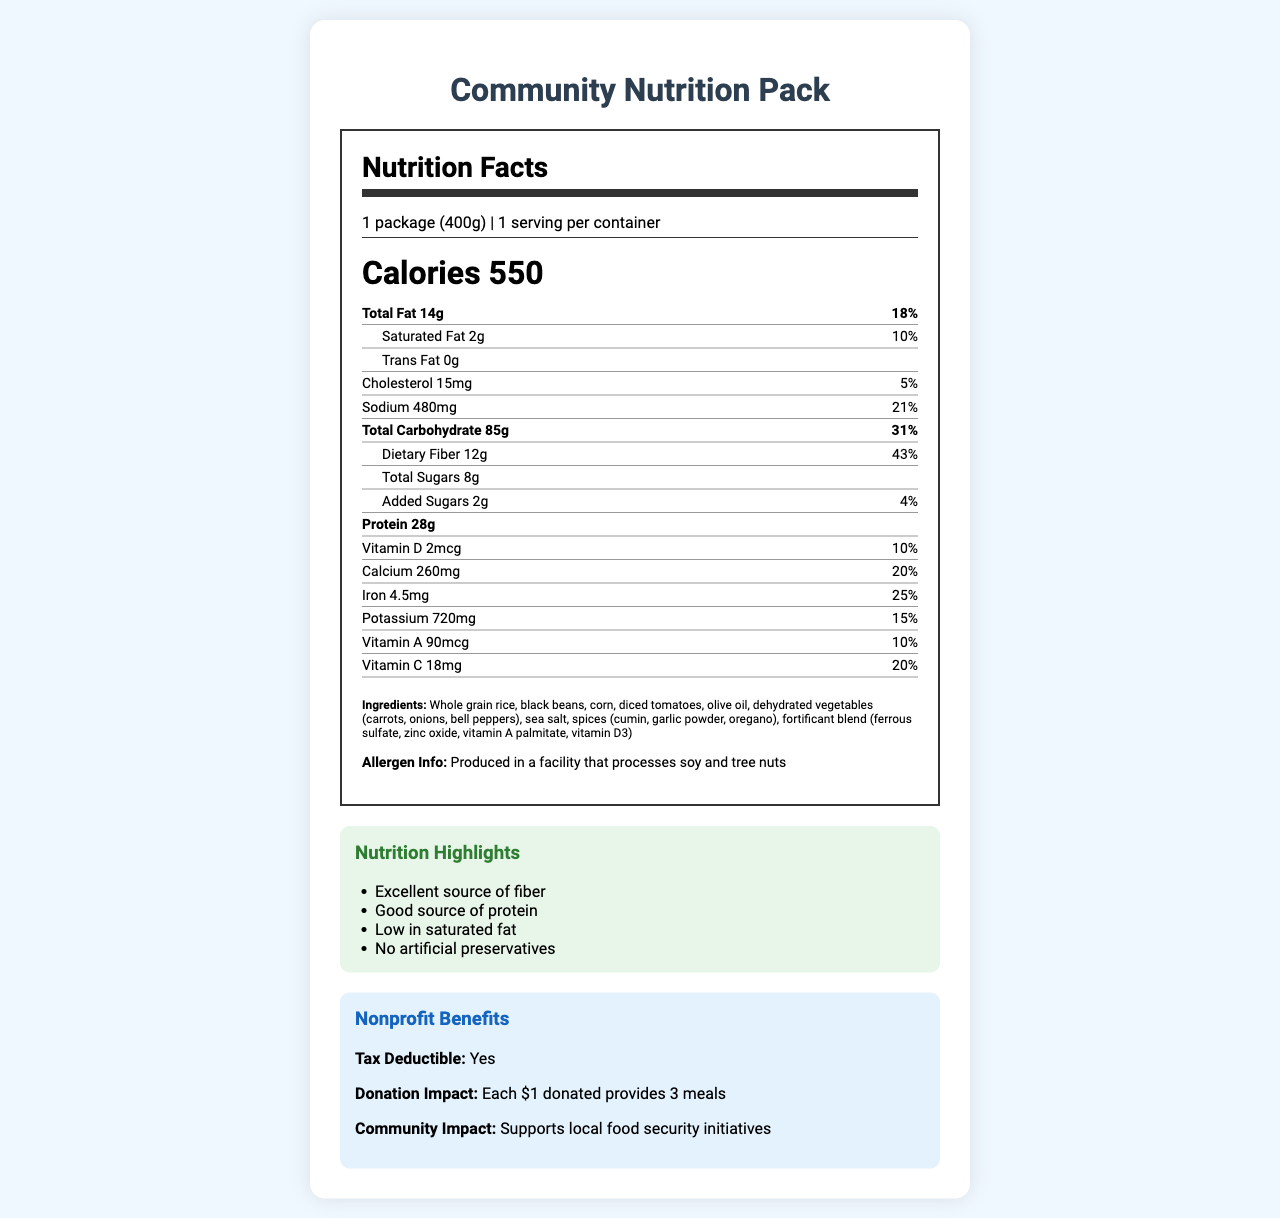what is the name of the product? The name of the product is clearly labeled at the top of the document.
Answer: Community Nutrition Pack how many servings per container are there? The document specifies "servings per container: 1" under the serving information.
Answer: 1 how many grams of dietary fiber does the product have? The amount of dietary fiber is listed as "Dietary Fiber 12g".
Answer: 12g what is the cost per serving? The cost per serving is mentioned as "$1.75" under the product details.
Answer: $1.75 what are the main ingredients of this product? The main ingredients are listed in the section "Ingredients".
Answer: Whole grain rice, black beans, corn, diced tomatoes, olive oil, dehydrated vegetables (carrots, onions, bell peppers), sea salt, spices (cumin, garlic powder, oregano), fortificant blend (ferrous sulfate, zinc oxide, vitamin A palmitate, vitamin D3) how many calories are in one serving? A. 400 B. 550 C. 600 D. 700 The document mentions "Calories 550".
Answer: B which nutrient has the highest daily value percentage? A. Total Fat B. Sodium C. Dietary Fiber D. Total Carbohydrate Dietary Fiber has the highest daily value percentage at 43%.
Answer: C is the product low in saturated fat? The product has "Saturated Fat 2g" which is 10% of the daily value, indicating it is relatively low.
Answer: Yes is the product tax-deductible for nonprofit donations? The document states "Tax Deductible: Yes" under the nonprofit benefits.
Answer: Yes summarize the main benefits of the Community Nutrition Pack document. The document emphasizes the nutritional value, cost-effectiveness, and benefits of the Community Nutrition Pack for nonprofits and food security.
Answer: The Community Nutrition Pack is a nutritious and cost-effective food item designed for community support, providing 550 calories per package with high fiber, good protein, and essential vitamins and minerals. It has no artificial preservatives and low saturated fat. It supports nonprofit donations, being tax-deductible and significantly impacting community food security. what is the exact percentage of Vitamin K in the product? The document does not mention Vitamin K content.
Answer: Not enough information 